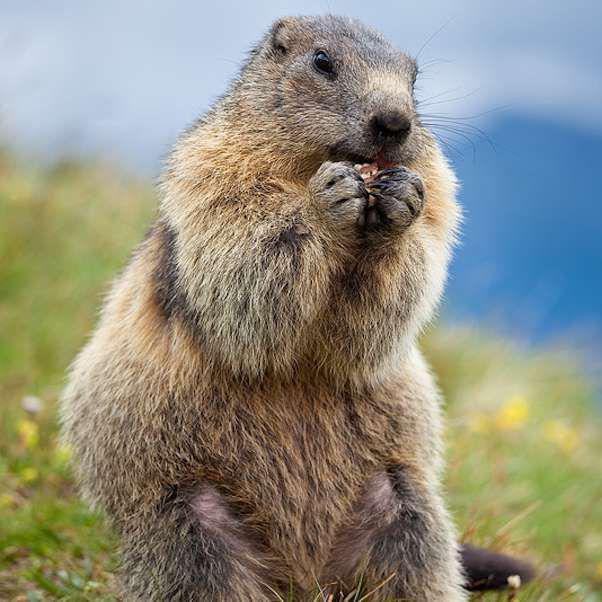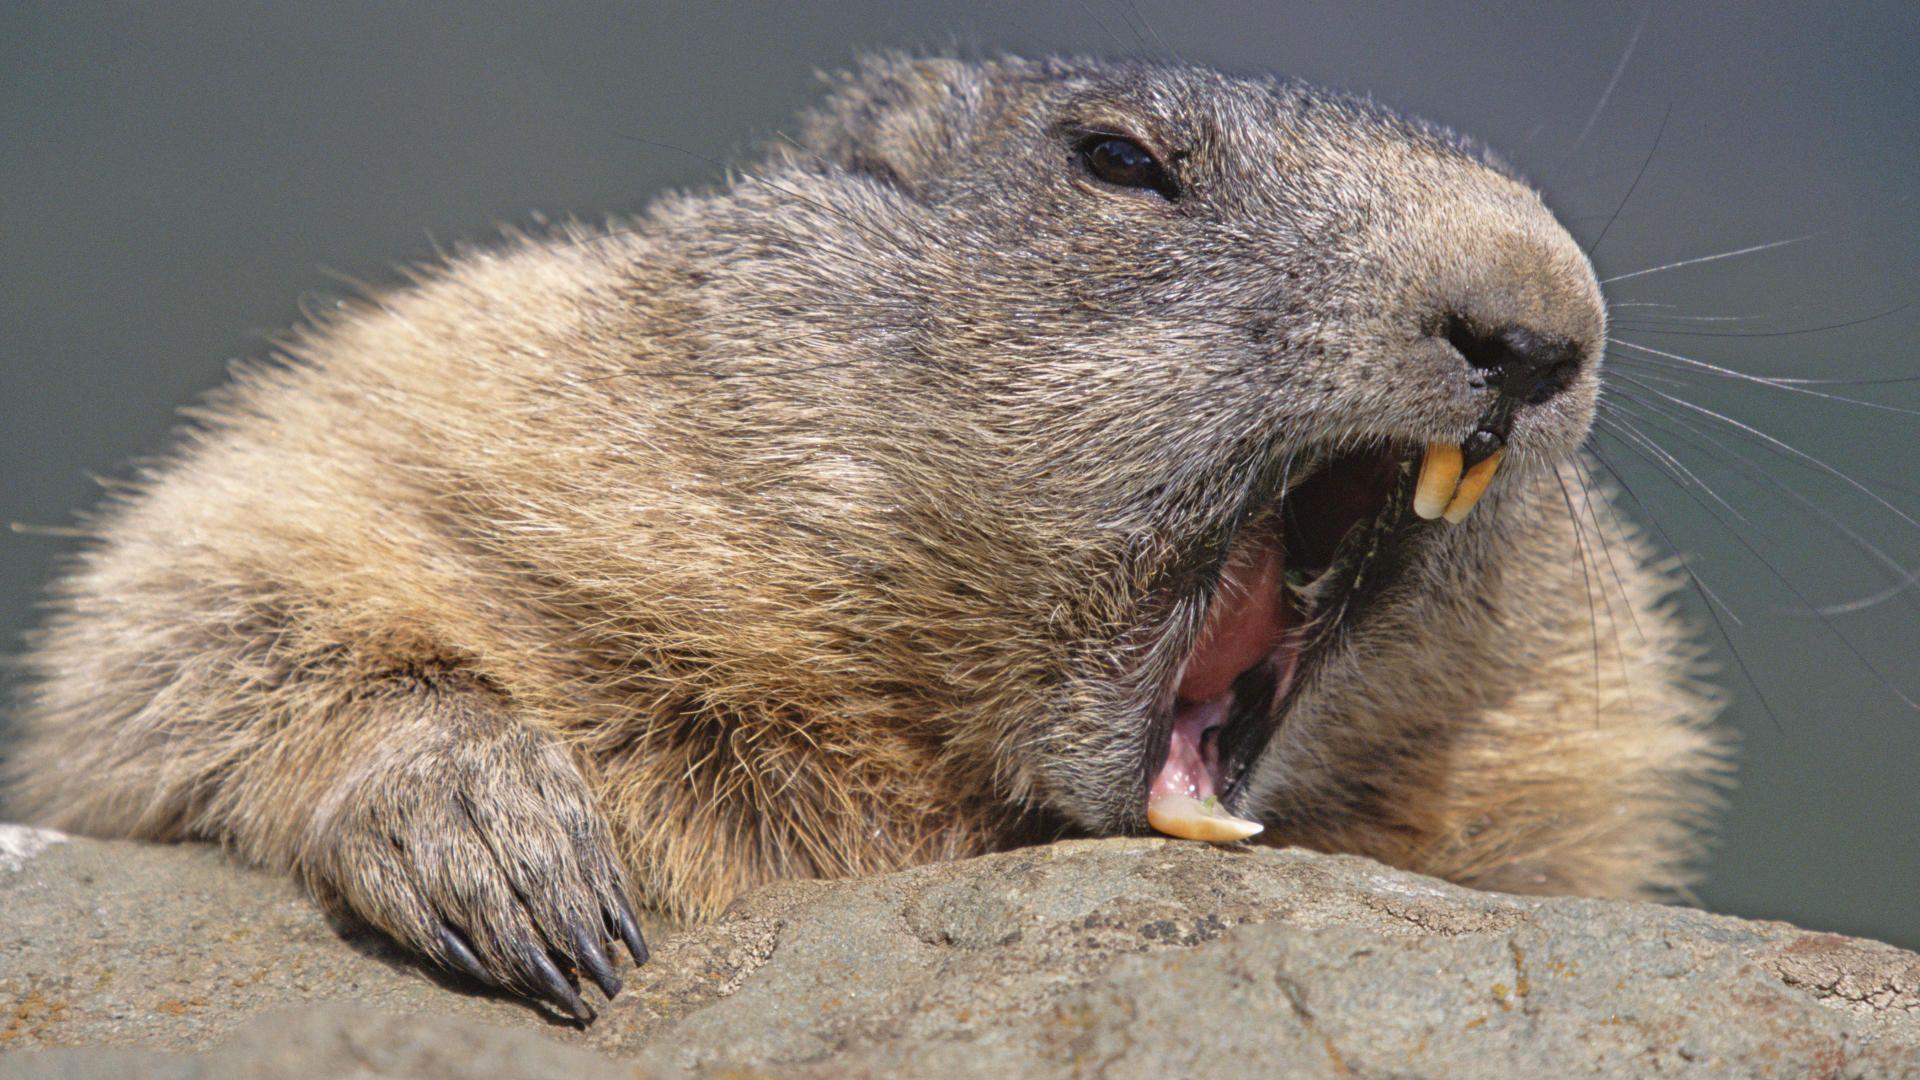The first image is the image on the left, the second image is the image on the right. Assess this claim about the two images: "In one image the prairie dog is eating food that it is holding in its paws.". Correct or not? Answer yes or no. Yes. 